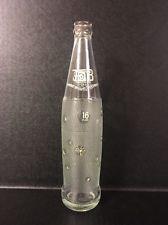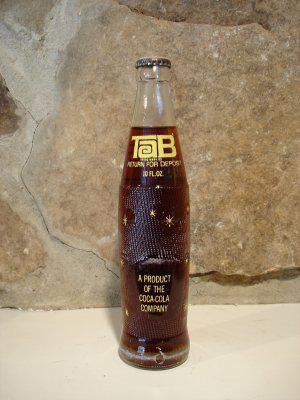The first image is the image on the left, the second image is the image on the right. Considering the images on both sides, is "One image shows an empty upright bottle with no cap, and the other shows a bottle of dark liquid with a cap on it." valid? Answer yes or no. Yes. 